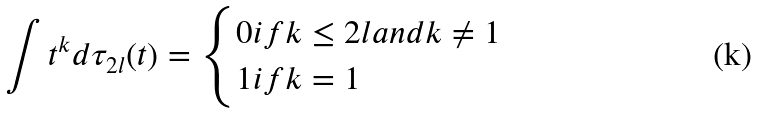<formula> <loc_0><loc_0><loc_500><loc_500>\int { t ^ { k } d \tau _ { 2 l } ( t ) } = \begin{cases} 0 i f k \leq 2 l a n d k \neq 1 \\ 1 i f k = 1 \end{cases}</formula> 